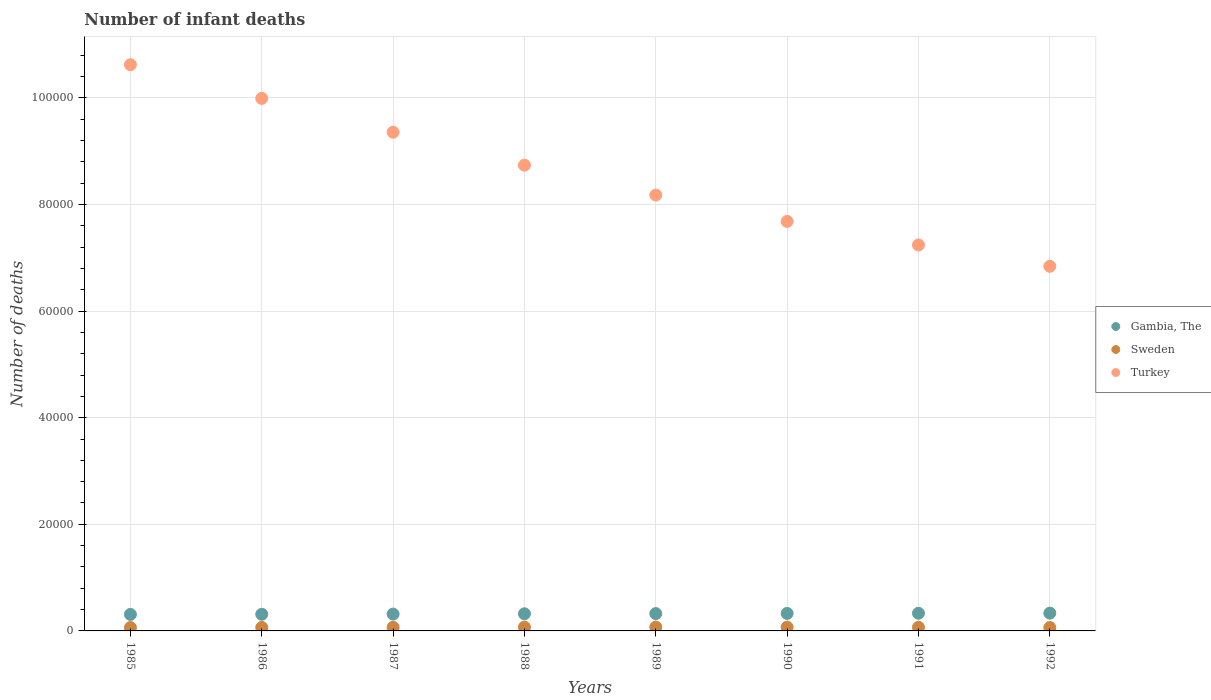How many different coloured dotlines are there?
Keep it short and to the point. 3. What is the number of infant deaths in Gambia, The in 1990?
Your answer should be very brief. 3278. Across all years, what is the maximum number of infant deaths in Turkey?
Your answer should be very brief. 1.06e+05. Across all years, what is the minimum number of infant deaths in Sweden?
Provide a short and direct response. 633. In which year was the number of infant deaths in Gambia, The minimum?
Provide a short and direct response. 1985. What is the total number of infant deaths in Turkey in the graph?
Provide a short and direct response. 6.86e+05. What is the difference between the number of infant deaths in Sweden in 1987 and that in 1990?
Your answer should be very brief. -29. What is the difference between the number of infant deaths in Sweden in 1992 and the number of infant deaths in Turkey in 1987?
Your answer should be compact. -9.29e+04. What is the average number of infant deaths in Turkey per year?
Offer a very short reply. 8.58e+04. In the year 1985, what is the difference between the number of infant deaths in Sweden and number of infant deaths in Turkey?
Your response must be concise. -1.06e+05. In how many years, is the number of infant deaths in Turkey greater than 40000?
Your answer should be very brief. 8. What is the ratio of the number of infant deaths in Sweden in 1988 to that in 1990?
Make the answer very short. 1. Is the difference between the number of infant deaths in Sweden in 1986 and 1990 greater than the difference between the number of infant deaths in Turkey in 1986 and 1990?
Offer a very short reply. No. What is the difference between the highest and the second highest number of infant deaths in Sweden?
Keep it short and to the point. 15. What is the difference between the highest and the lowest number of infant deaths in Gambia, The?
Offer a terse response. 237. Is the sum of the number of infant deaths in Gambia, The in 1985 and 1990 greater than the maximum number of infant deaths in Sweden across all years?
Provide a short and direct response. Yes. Is it the case that in every year, the sum of the number of infant deaths in Sweden and number of infant deaths in Gambia, The  is greater than the number of infant deaths in Turkey?
Ensure brevity in your answer.  No. Does the number of infant deaths in Gambia, The monotonically increase over the years?
Offer a very short reply. Yes. Is the number of infant deaths in Gambia, The strictly greater than the number of infant deaths in Turkey over the years?
Provide a short and direct response. No. Does the graph contain grids?
Your answer should be very brief. Yes. Where does the legend appear in the graph?
Your answer should be very brief. Center right. How are the legend labels stacked?
Ensure brevity in your answer.  Vertical. What is the title of the graph?
Ensure brevity in your answer.  Number of infant deaths. What is the label or title of the X-axis?
Offer a very short reply. Years. What is the label or title of the Y-axis?
Your answer should be compact. Number of deaths. What is the Number of deaths in Gambia, The in 1985?
Make the answer very short. 3099. What is the Number of deaths in Sweden in 1985?
Your response must be concise. 636. What is the Number of deaths in Turkey in 1985?
Your response must be concise. 1.06e+05. What is the Number of deaths in Gambia, The in 1986?
Your answer should be compact. 3123. What is the Number of deaths in Sweden in 1986?
Give a very brief answer. 653. What is the Number of deaths of Turkey in 1986?
Give a very brief answer. 9.99e+04. What is the Number of deaths in Gambia, The in 1987?
Give a very brief answer. 3163. What is the Number of deaths of Sweden in 1987?
Provide a short and direct response. 673. What is the Number of deaths of Turkey in 1987?
Keep it short and to the point. 9.36e+04. What is the Number of deaths of Gambia, The in 1988?
Offer a terse response. 3215. What is the Number of deaths of Sweden in 1988?
Offer a very short reply. 704. What is the Number of deaths of Turkey in 1988?
Keep it short and to the point. 8.74e+04. What is the Number of deaths of Gambia, The in 1989?
Give a very brief answer. 3255. What is the Number of deaths of Sweden in 1989?
Make the answer very short. 719. What is the Number of deaths of Turkey in 1989?
Your answer should be compact. 8.18e+04. What is the Number of deaths in Gambia, The in 1990?
Your answer should be compact. 3278. What is the Number of deaths of Sweden in 1990?
Offer a very short reply. 702. What is the Number of deaths of Turkey in 1990?
Give a very brief answer. 7.68e+04. What is the Number of deaths of Gambia, The in 1991?
Your answer should be very brief. 3315. What is the Number of deaths in Sweden in 1991?
Offer a terse response. 677. What is the Number of deaths of Turkey in 1991?
Offer a very short reply. 7.24e+04. What is the Number of deaths in Gambia, The in 1992?
Offer a terse response. 3336. What is the Number of deaths in Sweden in 1992?
Offer a terse response. 633. What is the Number of deaths of Turkey in 1992?
Keep it short and to the point. 6.84e+04. Across all years, what is the maximum Number of deaths in Gambia, The?
Your answer should be very brief. 3336. Across all years, what is the maximum Number of deaths of Sweden?
Your answer should be compact. 719. Across all years, what is the maximum Number of deaths of Turkey?
Offer a terse response. 1.06e+05. Across all years, what is the minimum Number of deaths in Gambia, The?
Offer a terse response. 3099. Across all years, what is the minimum Number of deaths of Sweden?
Provide a succinct answer. 633. Across all years, what is the minimum Number of deaths in Turkey?
Your response must be concise. 6.84e+04. What is the total Number of deaths in Gambia, The in the graph?
Make the answer very short. 2.58e+04. What is the total Number of deaths of Sweden in the graph?
Provide a succinct answer. 5397. What is the total Number of deaths of Turkey in the graph?
Give a very brief answer. 6.86e+05. What is the difference between the Number of deaths in Sweden in 1985 and that in 1986?
Keep it short and to the point. -17. What is the difference between the Number of deaths of Turkey in 1985 and that in 1986?
Give a very brief answer. 6320. What is the difference between the Number of deaths in Gambia, The in 1985 and that in 1987?
Provide a succinct answer. -64. What is the difference between the Number of deaths of Sweden in 1985 and that in 1987?
Your response must be concise. -37. What is the difference between the Number of deaths of Turkey in 1985 and that in 1987?
Your answer should be compact. 1.27e+04. What is the difference between the Number of deaths in Gambia, The in 1985 and that in 1988?
Give a very brief answer. -116. What is the difference between the Number of deaths in Sweden in 1985 and that in 1988?
Your answer should be compact. -68. What is the difference between the Number of deaths in Turkey in 1985 and that in 1988?
Keep it short and to the point. 1.88e+04. What is the difference between the Number of deaths in Gambia, The in 1985 and that in 1989?
Keep it short and to the point. -156. What is the difference between the Number of deaths in Sweden in 1985 and that in 1989?
Provide a succinct answer. -83. What is the difference between the Number of deaths in Turkey in 1985 and that in 1989?
Provide a succinct answer. 2.45e+04. What is the difference between the Number of deaths of Gambia, The in 1985 and that in 1990?
Your response must be concise. -179. What is the difference between the Number of deaths of Sweden in 1985 and that in 1990?
Your answer should be compact. -66. What is the difference between the Number of deaths in Turkey in 1985 and that in 1990?
Your answer should be compact. 2.94e+04. What is the difference between the Number of deaths of Gambia, The in 1985 and that in 1991?
Provide a short and direct response. -216. What is the difference between the Number of deaths in Sweden in 1985 and that in 1991?
Offer a terse response. -41. What is the difference between the Number of deaths of Turkey in 1985 and that in 1991?
Make the answer very short. 3.38e+04. What is the difference between the Number of deaths of Gambia, The in 1985 and that in 1992?
Give a very brief answer. -237. What is the difference between the Number of deaths in Turkey in 1985 and that in 1992?
Your answer should be compact. 3.78e+04. What is the difference between the Number of deaths in Sweden in 1986 and that in 1987?
Provide a short and direct response. -20. What is the difference between the Number of deaths of Turkey in 1986 and that in 1987?
Your response must be concise. 6349. What is the difference between the Number of deaths in Gambia, The in 1986 and that in 1988?
Give a very brief answer. -92. What is the difference between the Number of deaths of Sweden in 1986 and that in 1988?
Your answer should be very brief. -51. What is the difference between the Number of deaths of Turkey in 1986 and that in 1988?
Ensure brevity in your answer.  1.25e+04. What is the difference between the Number of deaths in Gambia, The in 1986 and that in 1989?
Your answer should be very brief. -132. What is the difference between the Number of deaths of Sweden in 1986 and that in 1989?
Keep it short and to the point. -66. What is the difference between the Number of deaths of Turkey in 1986 and that in 1989?
Your answer should be very brief. 1.81e+04. What is the difference between the Number of deaths in Gambia, The in 1986 and that in 1990?
Ensure brevity in your answer.  -155. What is the difference between the Number of deaths in Sweden in 1986 and that in 1990?
Provide a short and direct response. -49. What is the difference between the Number of deaths of Turkey in 1986 and that in 1990?
Provide a succinct answer. 2.31e+04. What is the difference between the Number of deaths of Gambia, The in 1986 and that in 1991?
Provide a succinct answer. -192. What is the difference between the Number of deaths in Turkey in 1986 and that in 1991?
Provide a short and direct response. 2.75e+04. What is the difference between the Number of deaths in Gambia, The in 1986 and that in 1992?
Offer a terse response. -213. What is the difference between the Number of deaths of Turkey in 1986 and that in 1992?
Ensure brevity in your answer.  3.15e+04. What is the difference between the Number of deaths in Gambia, The in 1987 and that in 1988?
Provide a short and direct response. -52. What is the difference between the Number of deaths of Sweden in 1987 and that in 1988?
Keep it short and to the point. -31. What is the difference between the Number of deaths in Turkey in 1987 and that in 1988?
Provide a short and direct response. 6172. What is the difference between the Number of deaths of Gambia, The in 1987 and that in 1989?
Provide a short and direct response. -92. What is the difference between the Number of deaths of Sweden in 1987 and that in 1989?
Give a very brief answer. -46. What is the difference between the Number of deaths in Turkey in 1987 and that in 1989?
Provide a short and direct response. 1.18e+04. What is the difference between the Number of deaths in Gambia, The in 1987 and that in 1990?
Your response must be concise. -115. What is the difference between the Number of deaths in Turkey in 1987 and that in 1990?
Offer a terse response. 1.67e+04. What is the difference between the Number of deaths of Gambia, The in 1987 and that in 1991?
Provide a short and direct response. -152. What is the difference between the Number of deaths in Sweden in 1987 and that in 1991?
Provide a succinct answer. -4. What is the difference between the Number of deaths of Turkey in 1987 and that in 1991?
Offer a terse response. 2.11e+04. What is the difference between the Number of deaths in Gambia, The in 1987 and that in 1992?
Offer a terse response. -173. What is the difference between the Number of deaths in Sweden in 1987 and that in 1992?
Offer a very short reply. 40. What is the difference between the Number of deaths of Turkey in 1987 and that in 1992?
Your response must be concise. 2.52e+04. What is the difference between the Number of deaths of Turkey in 1988 and that in 1989?
Ensure brevity in your answer.  5618. What is the difference between the Number of deaths in Gambia, The in 1988 and that in 1990?
Offer a terse response. -63. What is the difference between the Number of deaths of Turkey in 1988 and that in 1990?
Provide a short and direct response. 1.06e+04. What is the difference between the Number of deaths in Gambia, The in 1988 and that in 1991?
Your answer should be very brief. -100. What is the difference between the Number of deaths in Sweden in 1988 and that in 1991?
Provide a short and direct response. 27. What is the difference between the Number of deaths in Turkey in 1988 and that in 1991?
Ensure brevity in your answer.  1.50e+04. What is the difference between the Number of deaths in Gambia, The in 1988 and that in 1992?
Give a very brief answer. -121. What is the difference between the Number of deaths in Sweden in 1988 and that in 1992?
Give a very brief answer. 71. What is the difference between the Number of deaths in Turkey in 1988 and that in 1992?
Offer a very short reply. 1.90e+04. What is the difference between the Number of deaths in Turkey in 1989 and that in 1990?
Ensure brevity in your answer.  4938. What is the difference between the Number of deaths in Gambia, The in 1989 and that in 1991?
Provide a short and direct response. -60. What is the difference between the Number of deaths of Sweden in 1989 and that in 1991?
Offer a terse response. 42. What is the difference between the Number of deaths in Turkey in 1989 and that in 1991?
Make the answer very short. 9357. What is the difference between the Number of deaths in Gambia, The in 1989 and that in 1992?
Provide a short and direct response. -81. What is the difference between the Number of deaths of Turkey in 1989 and that in 1992?
Give a very brief answer. 1.34e+04. What is the difference between the Number of deaths of Gambia, The in 1990 and that in 1991?
Provide a short and direct response. -37. What is the difference between the Number of deaths of Sweden in 1990 and that in 1991?
Your answer should be compact. 25. What is the difference between the Number of deaths in Turkey in 1990 and that in 1991?
Give a very brief answer. 4419. What is the difference between the Number of deaths of Gambia, The in 1990 and that in 1992?
Your answer should be very brief. -58. What is the difference between the Number of deaths in Turkey in 1990 and that in 1992?
Ensure brevity in your answer.  8423. What is the difference between the Number of deaths in Gambia, The in 1991 and that in 1992?
Make the answer very short. -21. What is the difference between the Number of deaths in Sweden in 1991 and that in 1992?
Provide a succinct answer. 44. What is the difference between the Number of deaths in Turkey in 1991 and that in 1992?
Your answer should be compact. 4004. What is the difference between the Number of deaths in Gambia, The in 1985 and the Number of deaths in Sweden in 1986?
Offer a very short reply. 2446. What is the difference between the Number of deaths in Gambia, The in 1985 and the Number of deaths in Turkey in 1986?
Make the answer very short. -9.68e+04. What is the difference between the Number of deaths in Sweden in 1985 and the Number of deaths in Turkey in 1986?
Provide a succinct answer. -9.93e+04. What is the difference between the Number of deaths of Gambia, The in 1985 and the Number of deaths of Sweden in 1987?
Your response must be concise. 2426. What is the difference between the Number of deaths in Gambia, The in 1985 and the Number of deaths in Turkey in 1987?
Offer a terse response. -9.05e+04. What is the difference between the Number of deaths of Sweden in 1985 and the Number of deaths of Turkey in 1987?
Your answer should be very brief. -9.29e+04. What is the difference between the Number of deaths of Gambia, The in 1985 and the Number of deaths of Sweden in 1988?
Make the answer very short. 2395. What is the difference between the Number of deaths in Gambia, The in 1985 and the Number of deaths in Turkey in 1988?
Offer a very short reply. -8.43e+04. What is the difference between the Number of deaths in Sweden in 1985 and the Number of deaths in Turkey in 1988?
Ensure brevity in your answer.  -8.67e+04. What is the difference between the Number of deaths of Gambia, The in 1985 and the Number of deaths of Sweden in 1989?
Your answer should be compact. 2380. What is the difference between the Number of deaths in Gambia, The in 1985 and the Number of deaths in Turkey in 1989?
Your response must be concise. -7.87e+04. What is the difference between the Number of deaths of Sweden in 1985 and the Number of deaths of Turkey in 1989?
Your answer should be very brief. -8.11e+04. What is the difference between the Number of deaths of Gambia, The in 1985 and the Number of deaths of Sweden in 1990?
Ensure brevity in your answer.  2397. What is the difference between the Number of deaths in Gambia, The in 1985 and the Number of deaths in Turkey in 1990?
Ensure brevity in your answer.  -7.37e+04. What is the difference between the Number of deaths in Sweden in 1985 and the Number of deaths in Turkey in 1990?
Your answer should be compact. -7.62e+04. What is the difference between the Number of deaths in Gambia, The in 1985 and the Number of deaths in Sweden in 1991?
Provide a short and direct response. 2422. What is the difference between the Number of deaths in Gambia, The in 1985 and the Number of deaths in Turkey in 1991?
Your answer should be very brief. -6.93e+04. What is the difference between the Number of deaths of Sweden in 1985 and the Number of deaths of Turkey in 1991?
Your answer should be compact. -7.18e+04. What is the difference between the Number of deaths in Gambia, The in 1985 and the Number of deaths in Sweden in 1992?
Give a very brief answer. 2466. What is the difference between the Number of deaths of Gambia, The in 1985 and the Number of deaths of Turkey in 1992?
Ensure brevity in your answer.  -6.53e+04. What is the difference between the Number of deaths of Sweden in 1985 and the Number of deaths of Turkey in 1992?
Make the answer very short. -6.78e+04. What is the difference between the Number of deaths of Gambia, The in 1986 and the Number of deaths of Sweden in 1987?
Ensure brevity in your answer.  2450. What is the difference between the Number of deaths in Gambia, The in 1986 and the Number of deaths in Turkey in 1987?
Provide a short and direct response. -9.04e+04. What is the difference between the Number of deaths of Sweden in 1986 and the Number of deaths of Turkey in 1987?
Offer a very short reply. -9.29e+04. What is the difference between the Number of deaths in Gambia, The in 1986 and the Number of deaths in Sweden in 1988?
Give a very brief answer. 2419. What is the difference between the Number of deaths of Gambia, The in 1986 and the Number of deaths of Turkey in 1988?
Give a very brief answer. -8.43e+04. What is the difference between the Number of deaths of Sweden in 1986 and the Number of deaths of Turkey in 1988?
Give a very brief answer. -8.67e+04. What is the difference between the Number of deaths of Gambia, The in 1986 and the Number of deaths of Sweden in 1989?
Provide a succinct answer. 2404. What is the difference between the Number of deaths in Gambia, The in 1986 and the Number of deaths in Turkey in 1989?
Your answer should be compact. -7.86e+04. What is the difference between the Number of deaths in Sweden in 1986 and the Number of deaths in Turkey in 1989?
Offer a terse response. -8.11e+04. What is the difference between the Number of deaths of Gambia, The in 1986 and the Number of deaths of Sweden in 1990?
Make the answer very short. 2421. What is the difference between the Number of deaths of Gambia, The in 1986 and the Number of deaths of Turkey in 1990?
Keep it short and to the point. -7.37e+04. What is the difference between the Number of deaths in Sweden in 1986 and the Number of deaths in Turkey in 1990?
Provide a short and direct response. -7.62e+04. What is the difference between the Number of deaths of Gambia, The in 1986 and the Number of deaths of Sweden in 1991?
Ensure brevity in your answer.  2446. What is the difference between the Number of deaths of Gambia, The in 1986 and the Number of deaths of Turkey in 1991?
Your answer should be very brief. -6.93e+04. What is the difference between the Number of deaths in Sweden in 1986 and the Number of deaths in Turkey in 1991?
Your answer should be compact. -7.18e+04. What is the difference between the Number of deaths of Gambia, The in 1986 and the Number of deaths of Sweden in 1992?
Keep it short and to the point. 2490. What is the difference between the Number of deaths in Gambia, The in 1986 and the Number of deaths in Turkey in 1992?
Provide a short and direct response. -6.53e+04. What is the difference between the Number of deaths of Sweden in 1986 and the Number of deaths of Turkey in 1992?
Your response must be concise. -6.78e+04. What is the difference between the Number of deaths in Gambia, The in 1987 and the Number of deaths in Sweden in 1988?
Give a very brief answer. 2459. What is the difference between the Number of deaths in Gambia, The in 1987 and the Number of deaths in Turkey in 1988?
Offer a very short reply. -8.42e+04. What is the difference between the Number of deaths of Sweden in 1987 and the Number of deaths of Turkey in 1988?
Keep it short and to the point. -8.67e+04. What is the difference between the Number of deaths in Gambia, The in 1987 and the Number of deaths in Sweden in 1989?
Provide a short and direct response. 2444. What is the difference between the Number of deaths of Gambia, The in 1987 and the Number of deaths of Turkey in 1989?
Ensure brevity in your answer.  -7.86e+04. What is the difference between the Number of deaths of Sweden in 1987 and the Number of deaths of Turkey in 1989?
Offer a very short reply. -8.11e+04. What is the difference between the Number of deaths of Gambia, The in 1987 and the Number of deaths of Sweden in 1990?
Your answer should be very brief. 2461. What is the difference between the Number of deaths of Gambia, The in 1987 and the Number of deaths of Turkey in 1990?
Your answer should be very brief. -7.37e+04. What is the difference between the Number of deaths of Sweden in 1987 and the Number of deaths of Turkey in 1990?
Give a very brief answer. -7.62e+04. What is the difference between the Number of deaths of Gambia, The in 1987 and the Number of deaths of Sweden in 1991?
Offer a very short reply. 2486. What is the difference between the Number of deaths of Gambia, The in 1987 and the Number of deaths of Turkey in 1991?
Ensure brevity in your answer.  -6.92e+04. What is the difference between the Number of deaths of Sweden in 1987 and the Number of deaths of Turkey in 1991?
Make the answer very short. -7.17e+04. What is the difference between the Number of deaths of Gambia, The in 1987 and the Number of deaths of Sweden in 1992?
Your answer should be compact. 2530. What is the difference between the Number of deaths in Gambia, The in 1987 and the Number of deaths in Turkey in 1992?
Ensure brevity in your answer.  -6.52e+04. What is the difference between the Number of deaths in Sweden in 1987 and the Number of deaths in Turkey in 1992?
Provide a short and direct response. -6.77e+04. What is the difference between the Number of deaths in Gambia, The in 1988 and the Number of deaths in Sweden in 1989?
Your answer should be compact. 2496. What is the difference between the Number of deaths in Gambia, The in 1988 and the Number of deaths in Turkey in 1989?
Ensure brevity in your answer.  -7.86e+04. What is the difference between the Number of deaths in Sweden in 1988 and the Number of deaths in Turkey in 1989?
Make the answer very short. -8.11e+04. What is the difference between the Number of deaths in Gambia, The in 1988 and the Number of deaths in Sweden in 1990?
Provide a short and direct response. 2513. What is the difference between the Number of deaths of Gambia, The in 1988 and the Number of deaths of Turkey in 1990?
Your answer should be very brief. -7.36e+04. What is the difference between the Number of deaths in Sweden in 1988 and the Number of deaths in Turkey in 1990?
Make the answer very short. -7.61e+04. What is the difference between the Number of deaths in Gambia, The in 1988 and the Number of deaths in Sweden in 1991?
Make the answer very short. 2538. What is the difference between the Number of deaths in Gambia, The in 1988 and the Number of deaths in Turkey in 1991?
Offer a terse response. -6.92e+04. What is the difference between the Number of deaths in Sweden in 1988 and the Number of deaths in Turkey in 1991?
Ensure brevity in your answer.  -7.17e+04. What is the difference between the Number of deaths in Gambia, The in 1988 and the Number of deaths in Sweden in 1992?
Make the answer very short. 2582. What is the difference between the Number of deaths in Gambia, The in 1988 and the Number of deaths in Turkey in 1992?
Your answer should be very brief. -6.52e+04. What is the difference between the Number of deaths in Sweden in 1988 and the Number of deaths in Turkey in 1992?
Your answer should be compact. -6.77e+04. What is the difference between the Number of deaths of Gambia, The in 1989 and the Number of deaths of Sweden in 1990?
Provide a short and direct response. 2553. What is the difference between the Number of deaths in Gambia, The in 1989 and the Number of deaths in Turkey in 1990?
Offer a very short reply. -7.36e+04. What is the difference between the Number of deaths in Sweden in 1989 and the Number of deaths in Turkey in 1990?
Give a very brief answer. -7.61e+04. What is the difference between the Number of deaths of Gambia, The in 1989 and the Number of deaths of Sweden in 1991?
Make the answer very short. 2578. What is the difference between the Number of deaths in Gambia, The in 1989 and the Number of deaths in Turkey in 1991?
Your answer should be very brief. -6.92e+04. What is the difference between the Number of deaths in Sweden in 1989 and the Number of deaths in Turkey in 1991?
Keep it short and to the point. -7.17e+04. What is the difference between the Number of deaths of Gambia, The in 1989 and the Number of deaths of Sweden in 1992?
Keep it short and to the point. 2622. What is the difference between the Number of deaths in Gambia, The in 1989 and the Number of deaths in Turkey in 1992?
Offer a terse response. -6.52e+04. What is the difference between the Number of deaths of Sweden in 1989 and the Number of deaths of Turkey in 1992?
Your answer should be very brief. -6.77e+04. What is the difference between the Number of deaths of Gambia, The in 1990 and the Number of deaths of Sweden in 1991?
Provide a succinct answer. 2601. What is the difference between the Number of deaths in Gambia, The in 1990 and the Number of deaths in Turkey in 1991?
Keep it short and to the point. -6.91e+04. What is the difference between the Number of deaths of Sweden in 1990 and the Number of deaths of Turkey in 1991?
Your response must be concise. -7.17e+04. What is the difference between the Number of deaths in Gambia, The in 1990 and the Number of deaths in Sweden in 1992?
Your response must be concise. 2645. What is the difference between the Number of deaths in Gambia, The in 1990 and the Number of deaths in Turkey in 1992?
Provide a short and direct response. -6.51e+04. What is the difference between the Number of deaths in Sweden in 1990 and the Number of deaths in Turkey in 1992?
Provide a short and direct response. -6.77e+04. What is the difference between the Number of deaths in Gambia, The in 1991 and the Number of deaths in Sweden in 1992?
Your answer should be compact. 2682. What is the difference between the Number of deaths in Gambia, The in 1991 and the Number of deaths in Turkey in 1992?
Provide a short and direct response. -6.51e+04. What is the difference between the Number of deaths of Sweden in 1991 and the Number of deaths of Turkey in 1992?
Provide a short and direct response. -6.77e+04. What is the average Number of deaths in Gambia, The per year?
Your response must be concise. 3223. What is the average Number of deaths of Sweden per year?
Your answer should be very brief. 674.62. What is the average Number of deaths in Turkey per year?
Your response must be concise. 8.58e+04. In the year 1985, what is the difference between the Number of deaths in Gambia, The and Number of deaths in Sweden?
Ensure brevity in your answer.  2463. In the year 1985, what is the difference between the Number of deaths of Gambia, The and Number of deaths of Turkey?
Offer a terse response. -1.03e+05. In the year 1985, what is the difference between the Number of deaths of Sweden and Number of deaths of Turkey?
Make the answer very short. -1.06e+05. In the year 1986, what is the difference between the Number of deaths in Gambia, The and Number of deaths in Sweden?
Your answer should be very brief. 2470. In the year 1986, what is the difference between the Number of deaths in Gambia, The and Number of deaths in Turkey?
Offer a terse response. -9.68e+04. In the year 1986, what is the difference between the Number of deaths in Sweden and Number of deaths in Turkey?
Ensure brevity in your answer.  -9.93e+04. In the year 1987, what is the difference between the Number of deaths of Gambia, The and Number of deaths of Sweden?
Offer a very short reply. 2490. In the year 1987, what is the difference between the Number of deaths in Gambia, The and Number of deaths in Turkey?
Ensure brevity in your answer.  -9.04e+04. In the year 1987, what is the difference between the Number of deaths of Sweden and Number of deaths of Turkey?
Make the answer very short. -9.29e+04. In the year 1988, what is the difference between the Number of deaths in Gambia, The and Number of deaths in Sweden?
Your answer should be compact. 2511. In the year 1988, what is the difference between the Number of deaths of Gambia, The and Number of deaths of Turkey?
Offer a terse response. -8.42e+04. In the year 1988, what is the difference between the Number of deaths in Sweden and Number of deaths in Turkey?
Your answer should be very brief. -8.67e+04. In the year 1989, what is the difference between the Number of deaths of Gambia, The and Number of deaths of Sweden?
Make the answer very short. 2536. In the year 1989, what is the difference between the Number of deaths of Gambia, The and Number of deaths of Turkey?
Your response must be concise. -7.85e+04. In the year 1989, what is the difference between the Number of deaths of Sweden and Number of deaths of Turkey?
Your answer should be compact. -8.10e+04. In the year 1990, what is the difference between the Number of deaths in Gambia, The and Number of deaths in Sweden?
Give a very brief answer. 2576. In the year 1990, what is the difference between the Number of deaths of Gambia, The and Number of deaths of Turkey?
Your response must be concise. -7.36e+04. In the year 1990, what is the difference between the Number of deaths in Sweden and Number of deaths in Turkey?
Provide a short and direct response. -7.61e+04. In the year 1991, what is the difference between the Number of deaths in Gambia, The and Number of deaths in Sweden?
Offer a very short reply. 2638. In the year 1991, what is the difference between the Number of deaths in Gambia, The and Number of deaths in Turkey?
Offer a very short reply. -6.91e+04. In the year 1991, what is the difference between the Number of deaths in Sweden and Number of deaths in Turkey?
Give a very brief answer. -7.17e+04. In the year 1992, what is the difference between the Number of deaths of Gambia, The and Number of deaths of Sweden?
Keep it short and to the point. 2703. In the year 1992, what is the difference between the Number of deaths in Gambia, The and Number of deaths in Turkey?
Provide a short and direct response. -6.51e+04. In the year 1992, what is the difference between the Number of deaths of Sweden and Number of deaths of Turkey?
Provide a succinct answer. -6.78e+04. What is the ratio of the Number of deaths of Sweden in 1985 to that in 1986?
Your response must be concise. 0.97. What is the ratio of the Number of deaths in Turkey in 1985 to that in 1986?
Keep it short and to the point. 1.06. What is the ratio of the Number of deaths of Gambia, The in 1985 to that in 1987?
Provide a short and direct response. 0.98. What is the ratio of the Number of deaths in Sweden in 1985 to that in 1987?
Offer a terse response. 0.94. What is the ratio of the Number of deaths of Turkey in 1985 to that in 1987?
Ensure brevity in your answer.  1.14. What is the ratio of the Number of deaths in Gambia, The in 1985 to that in 1988?
Offer a terse response. 0.96. What is the ratio of the Number of deaths in Sweden in 1985 to that in 1988?
Keep it short and to the point. 0.9. What is the ratio of the Number of deaths of Turkey in 1985 to that in 1988?
Give a very brief answer. 1.22. What is the ratio of the Number of deaths in Gambia, The in 1985 to that in 1989?
Provide a short and direct response. 0.95. What is the ratio of the Number of deaths in Sweden in 1985 to that in 1989?
Make the answer very short. 0.88. What is the ratio of the Number of deaths of Turkey in 1985 to that in 1989?
Give a very brief answer. 1.3. What is the ratio of the Number of deaths of Gambia, The in 1985 to that in 1990?
Offer a very short reply. 0.95. What is the ratio of the Number of deaths of Sweden in 1985 to that in 1990?
Keep it short and to the point. 0.91. What is the ratio of the Number of deaths in Turkey in 1985 to that in 1990?
Offer a very short reply. 1.38. What is the ratio of the Number of deaths in Gambia, The in 1985 to that in 1991?
Provide a short and direct response. 0.93. What is the ratio of the Number of deaths of Sweden in 1985 to that in 1991?
Your answer should be compact. 0.94. What is the ratio of the Number of deaths in Turkey in 1985 to that in 1991?
Provide a succinct answer. 1.47. What is the ratio of the Number of deaths in Gambia, The in 1985 to that in 1992?
Your response must be concise. 0.93. What is the ratio of the Number of deaths of Turkey in 1985 to that in 1992?
Your answer should be compact. 1.55. What is the ratio of the Number of deaths of Gambia, The in 1986 to that in 1987?
Give a very brief answer. 0.99. What is the ratio of the Number of deaths of Sweden in 1986 to that in 1987?
Your response must be concise. 0.97. What is the ratio of the Number of deaths of Turkey in 1986 to that in 1987?
Your answer should be very brief. 1.07. What is the ratio of the Number of deaths of Gambia, The in 1986 to that in 1988?
Your answer should be compact. 0.97. What is the ratio of the Number of deaths in Sweden in 1986 to that in 1988?
Offer a very short reply. 0.93. What is the ratio of the Number of deaths in Turkey in 1986 to that in 1988?
Your answer should be very brief. 1.14. What is the ratio of the Number of deaths in Gambia, The in 1986 to that in 1989?
Ensure brevity in your answer.  0.96. What is the ratio of the Number of deaths of Sweden in 1986 to that in 1989?
Give a very brief answer. 0.91. What is the ratio of the Number of deaths of Turkey in 1986 to that in 1989?
Offer a very short reply. 1.22. What is the ratio of the Number of deaths of Gambia, The in 1986 to that in 1990?
Your answer should be compact. 0.95. What is the ratio of the Number of deaths of Sweden in 1986 to that in 1990?
Offer a very short reply. 0.93. What is the ratio of the Number of deaths of Turkey in 1986 to that in 1990?
Keep it short and to the point. 1.3. What is the ratio of the Number of deaths of Gambia, The in 1986 to that in 1991?
Provide a succinct answer. 0.94. What is the ratio of the Number of deaths in Sweden in 1986 to that in 1991?
Your response must be concise. 0.96. What is the ratio of the Number of deaths in Turkey in 1986 to that in 1991?
Offer a terse response. 1.38. What is the ratio of the Number of deaths in Gambia, The in 1986 to that in 1992?
Provide a succinct answer. 0.94. What is the ratio of the Number of deaths of Sweden in 1986 to that in 1992?
Your answer should be very brief. 1.03. What is the ratio of the Number of deaths of Turkey in 1986 to that in 1992?
Provide a succinct answer. 1.46. What is the ratio of the Number of deaths in Gambia, The in 1987 to that in 1988?
Make the answer very short. 0.98. What is the ratio of the Number of deaths in Sweden in 1987 to that in 1988?
Your answer should be compact. 0.96. What is the ratio of the Number of deaths of Turkey in 1987 to that in 1988?
Your answer should be very brief. 1.07. What is the ratio of the Number of deaths in Gambia, The in 1987 to that in 1989?
Provide a short and direct response. 0.97. What is the ratio of the Number of deaths in Sweden in 1987 to that in 1989?
Your answer should be very brief. 0.94. What is the ratio of the Number of deaths of Turkey in 1987 to that in 1989?
Offer a very short reply. 1.14. What is the ratio of the Number of deaths of Gambia, The in 1987 to that in 1990?
Ensure brevity in your answer.  0.96. What is the ratio of the Number of deaths in Sweden in 1987 to that in 1990?
Give a very brief answer. 0.96. What is the ratio of the Number of deaths in Turkey in 1987 to that in 1990?
Keep it short and to the point. 1.22. What is the ratio of the Number of deaths of Gambia, The in 1987 to that in 1991?
Make the answer very short. 0.95. What is the ratio of the Number of deaths of Turkey in 1987 to that in 1991?
Keep it short and to the point. 1.29. What is the ratio of the Number of deaths in Gambia, The in 1987 to that in 1992?
Your answer should be very brief. 0.95. What is the ratio of the Number of deaths in Sweden in 1987 to that in 1992?
Your answer should be very brief. 1.06. What is the ratio of the Number of deaths of Turkey in 1987 to that in 1992?
Your response must be concise. 1.37. What is the ratio of the Number of deaths of Gambia, The in 1988 to that in 1989?
Make the answer very short. 0.99. What is the ratio of the Number of deaths in Sweden in 1988 to that in 1989?
Your response must be concise. 0.98. What is the ratio of the Number of deaths in Turkey in 1988 to that in 1989?
Offer a terse response. 1.07. What is the ratio of the Number of deaths in Gambia, The in 1988 to that in 1990?
Give a very brief answer. 0.98. What is the ratio of the Number of deaths of Sweden in 1988 to that in 1990?
Ensure brevity in your answer.  1. What is the ratio of the Number of deaths of Turkey in 1988 to that in 1990?
Give a very brief answer. 1.14. What is the ratio of the Number of deaths of Gambia, The in 1988 to that in 1991?
Your answer should be compact. 0.97. What is the ratio of the Number of deaths of Sweden in 1988 to that in 1991?
Ensure brevity in your answer.  1.04. What is the ratio of the Number of deaths of Turkey in 1988 to that in 1991?
Provide a succinct answer. 1.21. What is the ratio of the Number of deaths in Gambia, The in 1988 to that in 1992?
Provide a succinct answer. 0.96. What is the ratio of the Number of deaths in Sweden in 1988 to that in 1992?
Provide a succinct answer. 1.11. What is the ratio of the Number of deaths of Turkey in 1988 to that in 1992?
Provide a short and direct response. 1.28. What is the ratio of the Number of deaths in Sweden in 1989 to that in 1990?
Offer a terse response. 1.02. What is the ratio of the Number of deaths of Turkey in 1989 to that in 1990?
Your response must be concise. 1.06. What is the ratio of the Number of deaths in Gambia, The in 1989 to that in 1991?
Give a very brief answer. 0.98. What is the ratio of the Number of deaths of Sweden in 1989 to that in 1991?
Provide a succinct answer. 1.06. What is the ratio of the Number of deaths in Turkey in 1989 to that in 1991?
Your response must be concise. 1.13. What is the ratio of the Number of deaths in Gambia, The in 1989 to that in 1992?
Make the answer very short. 0.98. What is the ratio of the Number of deaths of Sweden in 1989 to that in 1992?
Give a very brief answer. 1.14. What is the ratio of the Number of deaths in Turkey in 1989 to that in 1992?
Offer a very short reply. 1.2. What is the ratio of the Number of deaths in Sweden in 1990 to that in 1991?
Keep it short and to the point. 1.04. What is the ratio of the Number of deaths of Turkey in 1990 to that in 1991?
Provide a succinct answer. 1.06. What is the ratio of the Number of deaths in Gambia, The in 1990 to that in 1992?
Make the answer very short. 0.98. What is the ratio of the Number of deaths in Sweden in 1990 to that in 1992?
Give a very brief answer. 1.11. What is the ratio of the Number of deaths of Turkey in 1990 to that in 1992?
Provide a short and direct response. 1.12. What is the ratio of the Number of deaths in Gambia, The in 1991 to that in 1992?
Give a very brief answer. 0.99. What is the ratio of the Number of deaths of Sweden in 1991 to that in 1992?
Keep it short and to the point. 1.07. What is the ratio of the Number of deaths in Turkey in 1991 to that in 1992?
Your answer should be very brief. 1.06. What is the difference between the highest and the second highest Number of deaths in Gambia, The?
Provide a short and direct response. 21. What is the difference between the highest and the second highest Number of deaths of Turkey?
Make the answer very short. 6320. What is the difference between the highest and the lowest Number of deaths in Gambia, The?
Keep it short and to the point. 237. What is the difference between the highest and the lowest Number of deaths in Turkey?
Ensure brevity in your answer.  3.78e+04. 